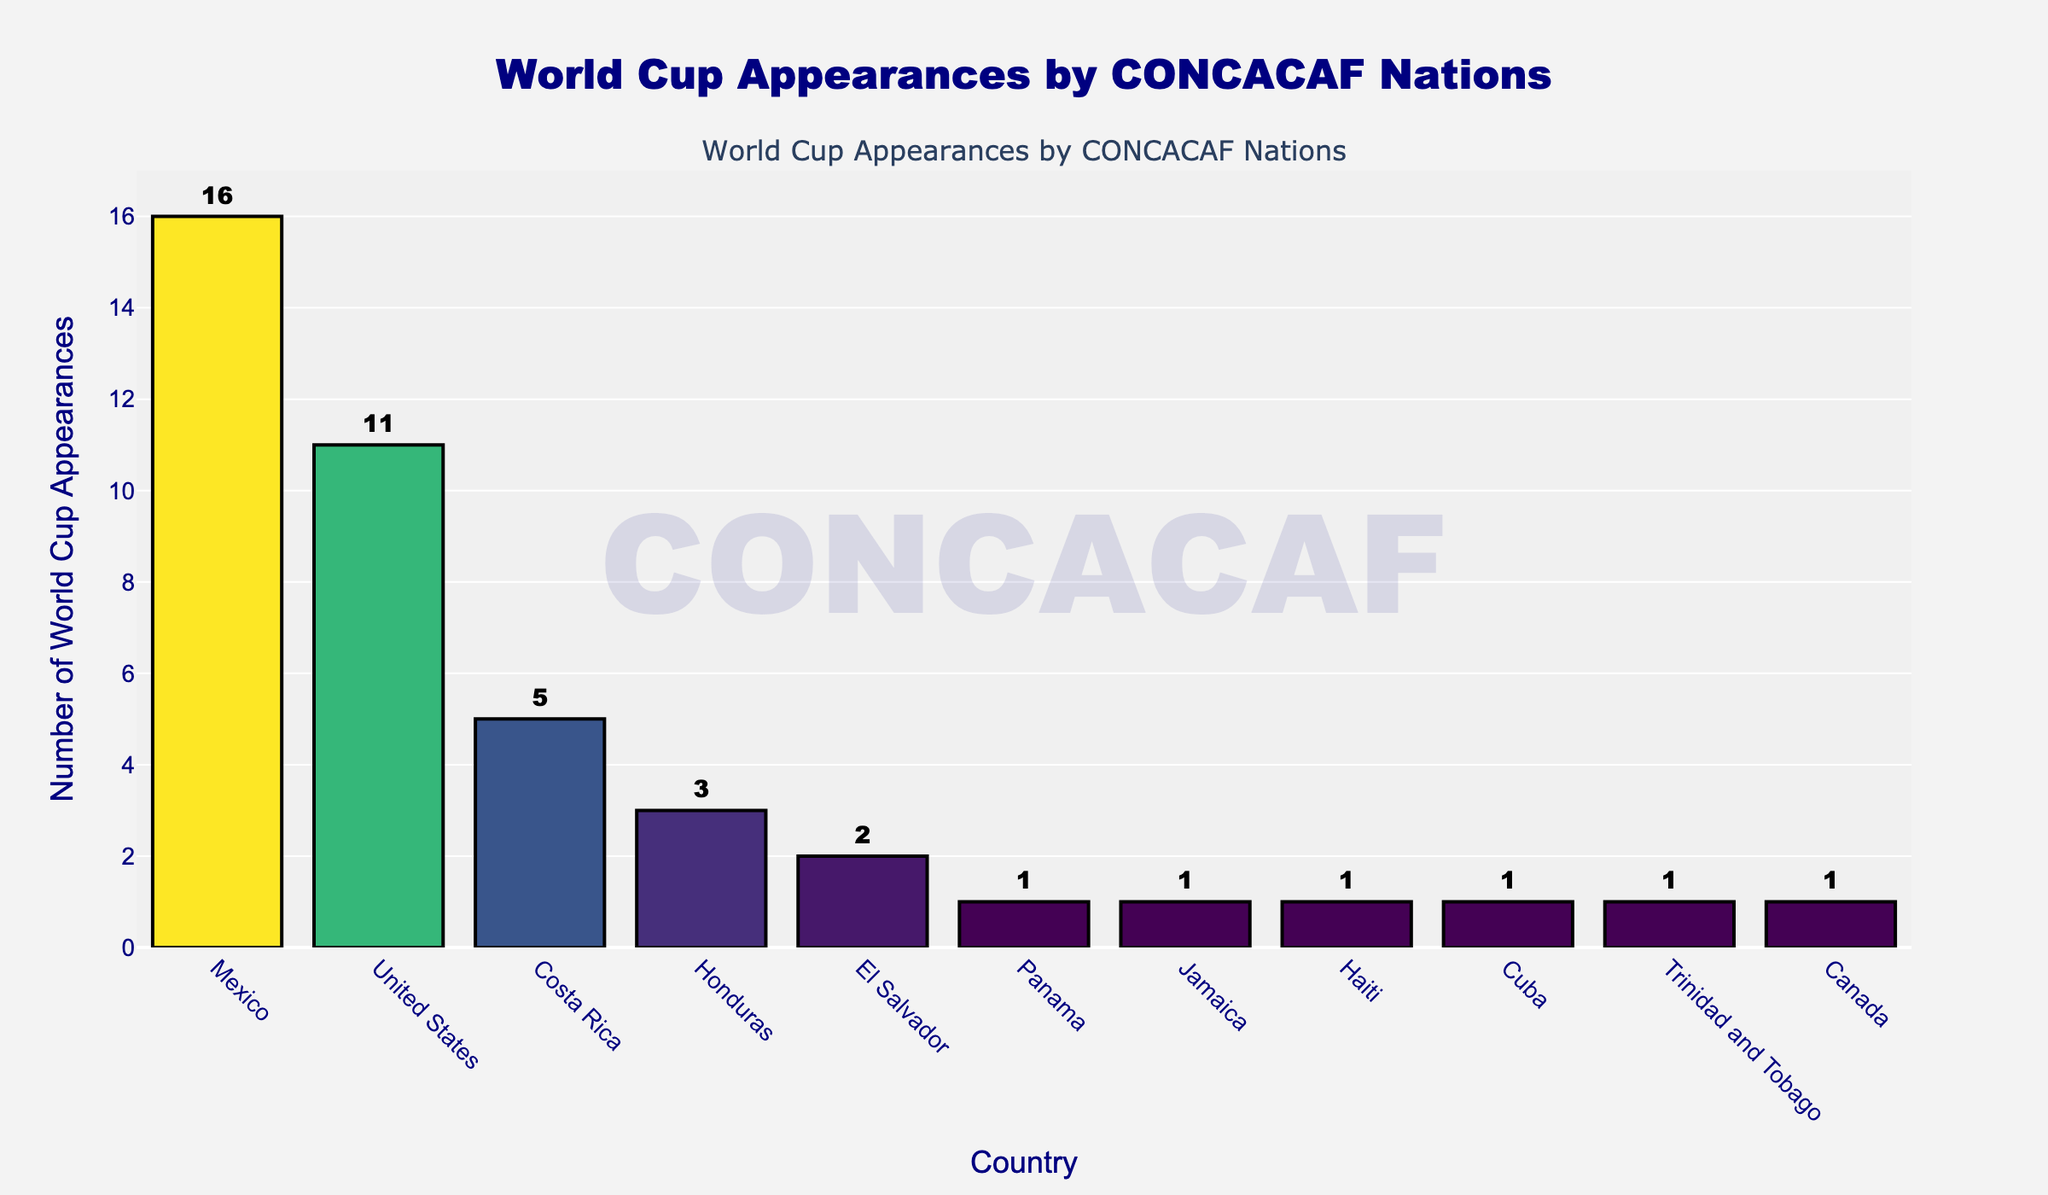What country has the most World Cup appearances in CONCACAF? The tallest bar in the bar chart represents the country with the most World Cup appearances. By looking at the highest bar, we can see that Mexico has the most appearances.
Answer: Mexico What's the difference in World Cup appearances between the United States and Costa Rica? To find the difference, look at the heights of the bars for the United States and Costa Rica. The United States has 11 appearances and Costa Rica has 5 appearances. Subtract 5 from 11 to get the difference.
Answer: 6 How many countries have made only 1 World Cup appearance? To answer this, count the number of bars that have a height corresponding to 1 World Cup appearance. The countries with 1 appearance are Panama, Jamaica, Haiti, Cuba, Trinidad and Tobago, and Canada. There are 6 such countries.
Answer: 6 Which country has the same number of World Cup appearances as Canada? To find the answer, look for the country with a bar height the same as Canada's. Canada has 1 appearance. By examining the chart, we also see that Panama, Jamaica, Haiti, Cuba, and Trinidad and Tobago each have 1 appearance.
Answer: Panama, Jamaica, Haiti, Cuba, Trinidad and Tobago What is the total number of World Cup appearances by the top 3 countries? Sum the World Cup appearances of Mexico, the United States, and Costa Rica. Mexico has 16, the United States has 11, and Costa Rica has 5. Add these together: 16 + 11 + 5 = 32.
Answer: 32 Which countries have a smaller number of World Cup appearances than Honduras but more than Trinidad and Tobago? First, identify the number of appearances for Honduras (3) and Trinidad and Tobago (1). Next, look for countries with 2 appearances (El Salvador) since it’s the only bar between 3 and 1.
Answer: El Salvador Is there more than one country with exactly 2 World Cup appearances? Look at the bar chart to find any countries with a bar height of 2. Only El Salvador has 2 World Cup appearances, so no, there is only one.
Answer: No What is the sum of World Cup appearances by countries that have fewer than 3 appearances each? Sum the World Cup appearances of El Salvador (2), Panama (1), Jamaica (1), Haiti (1), Cuba (1), Trinidad and Tobago (1), and Canada (1): 2 + 1 + 1 + 1 + 1 + 1 + 1 = 8.
Answer: 8 Which countries tie in terms of their World Cup appearances? By examining the bars, we see that Panama, Jamaica, Haiti, Cuba, Trinidad and Tobago, and Canada each have 1 appearance. These countries tie in their number of appearances.
Answer: Panama, Jamaica, Haiti, Cuba, Trinidad and Tobago, Canada 